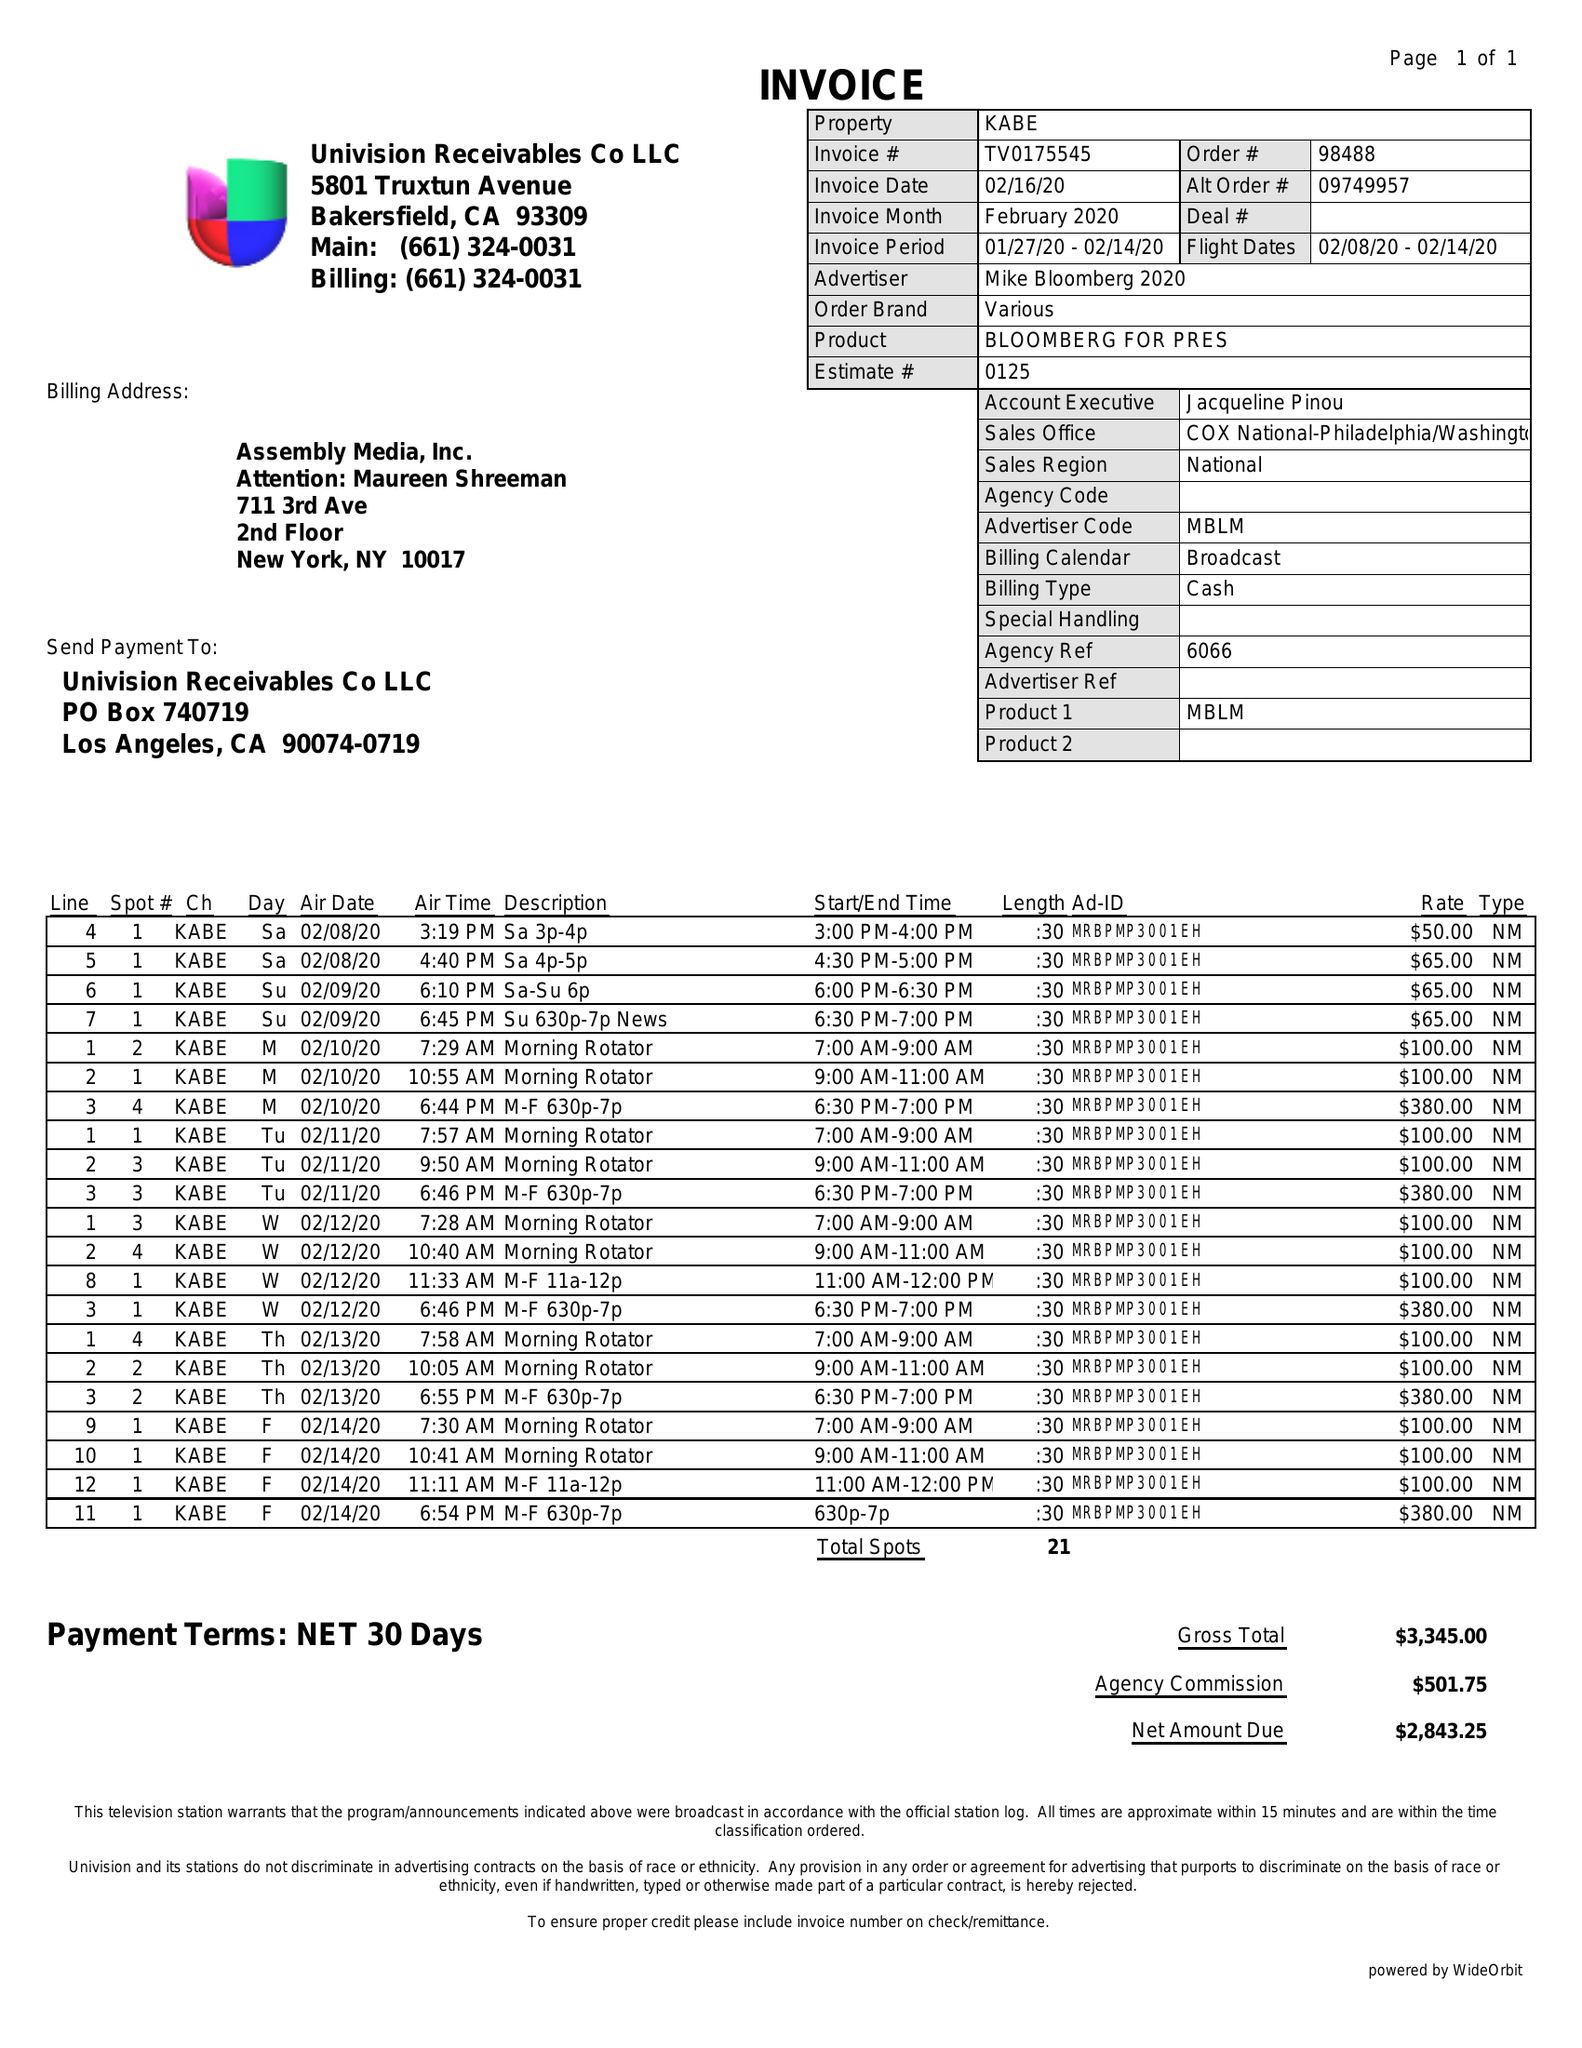What is the value for the flight_to?
Answer the question using a single word or phrase. 02/14/20 